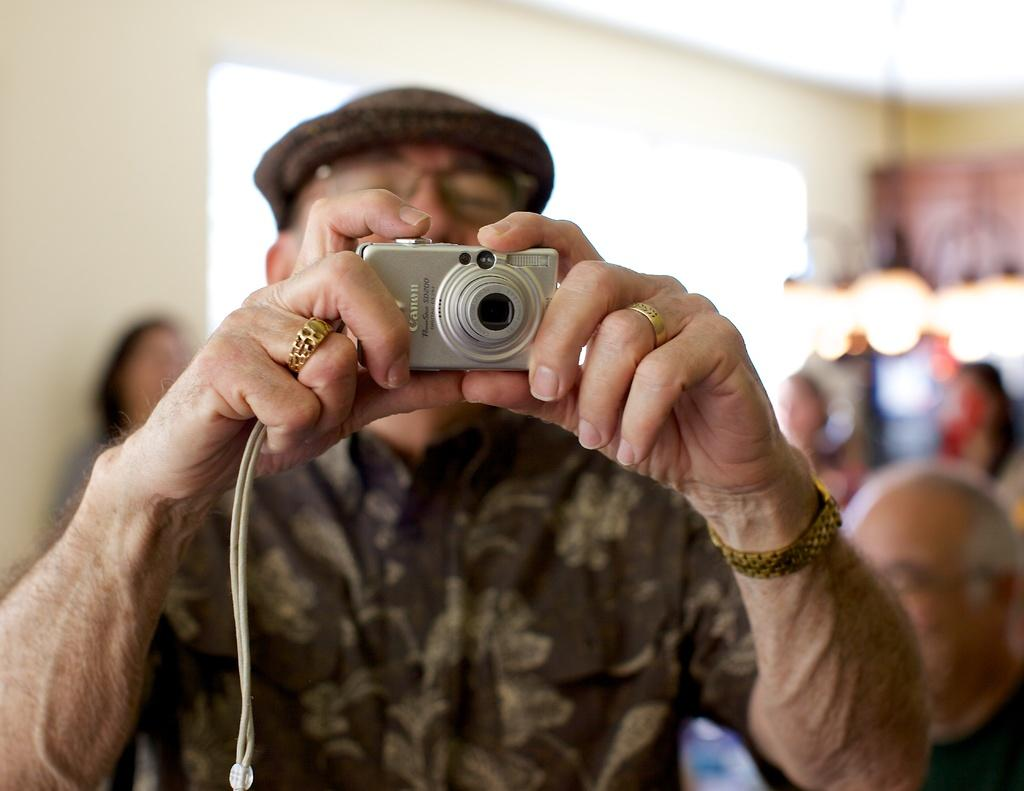Who is present in the image? There is a man in the image. What is the man holding in the image? The man is holding a Canon camera. What can be seen in the background of the image? There is a group of people sitting in the background of the image. What type of destruction can be seen in the image? There is no destruction present in the image; it features a man holding a camera and a group of people sitting in the background. Can you tell me how many snails are visible in the image? There are no snails present in the image. 